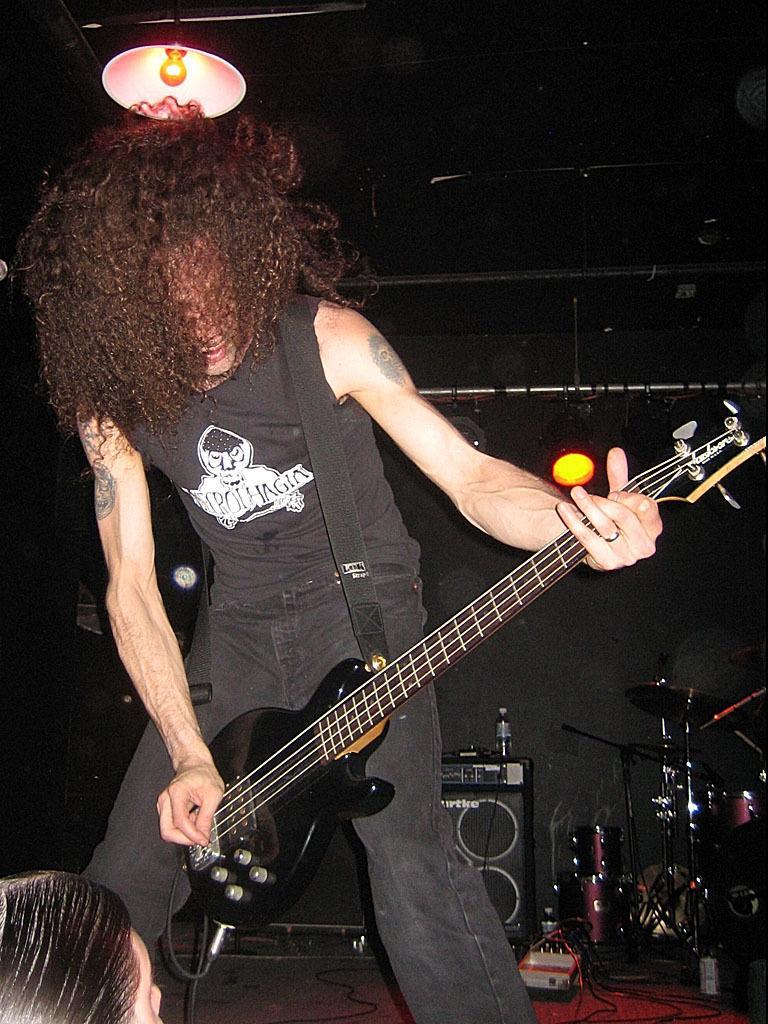In one or two sentences, can you explain what this image depicts? In this picture we can see a man playing a guitar in hand and wearing a black T-shirt and curly hair, In back ground we can see speakers and a band with cable and on the ceiling with a spot light. 